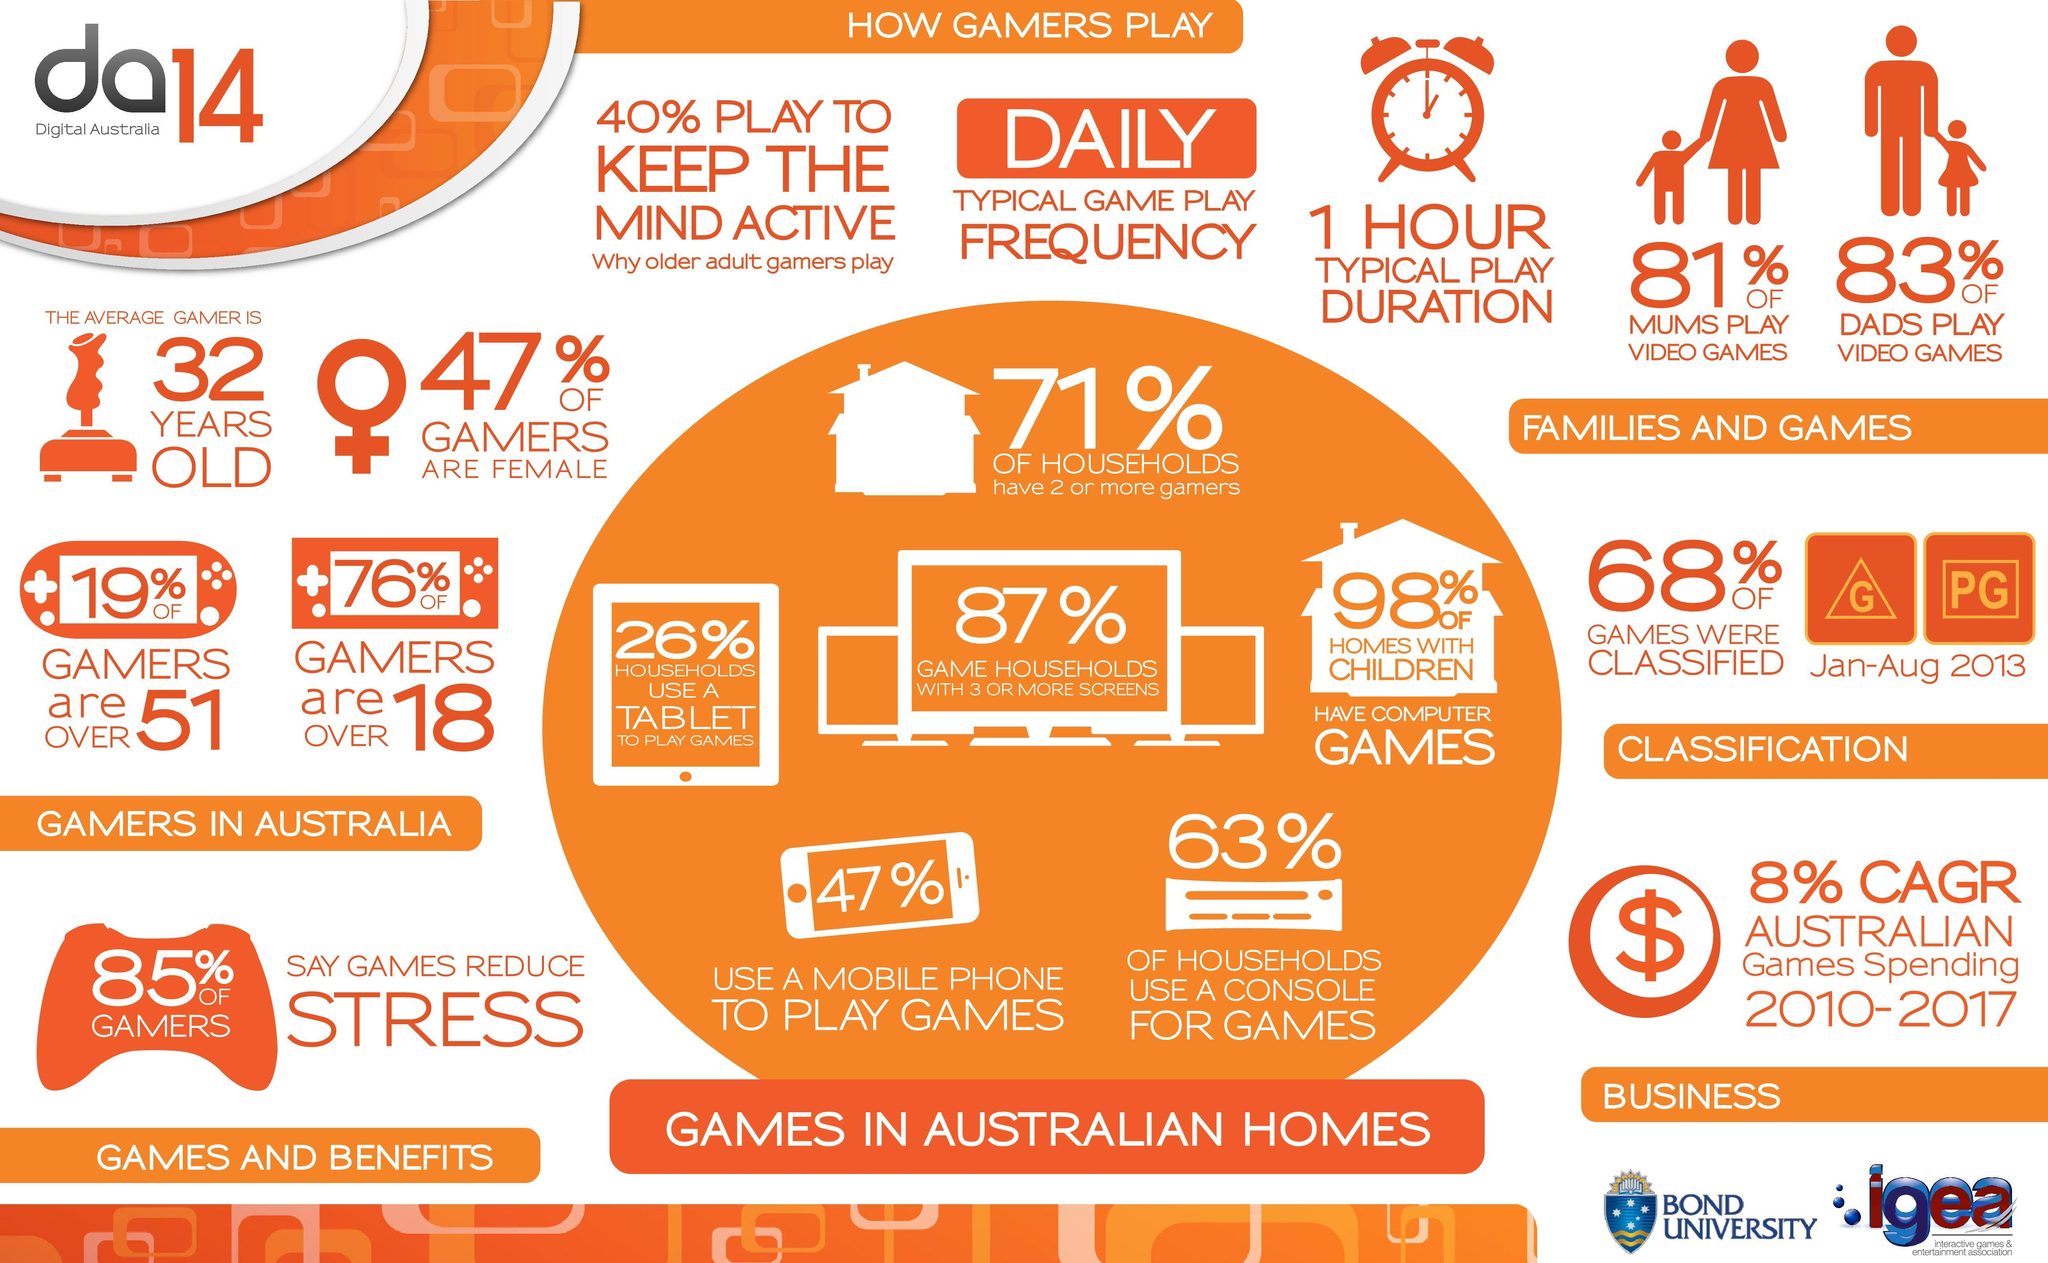What per cent of households in Australia use a tablet to play games in 2014?
Answer the question with a short phrase. 26% What is the average gamer age in Australia in 2014? 32 YEARS OLD What percentage of the gamers in Australia are male in 2014? 53% What percentage of gamers in Australia do not say that games reduce stress in 2014? 15% What percent of homes with children in Australia do not have computer games in 2014? 2% What percent of the gamers in Australia use a mobile phone to play games in 2014? 47% 